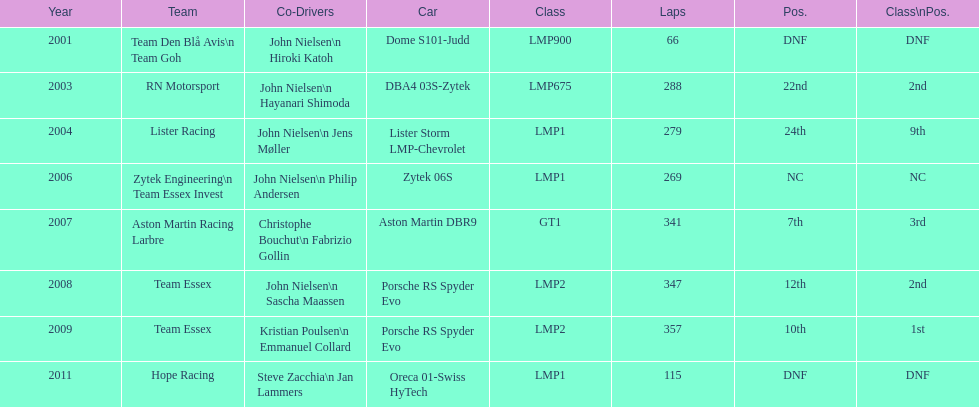Who were the partner drivers for the aston martin dbr9 in 2007? Christophe Bouchut, Fabrizio Gollin. 